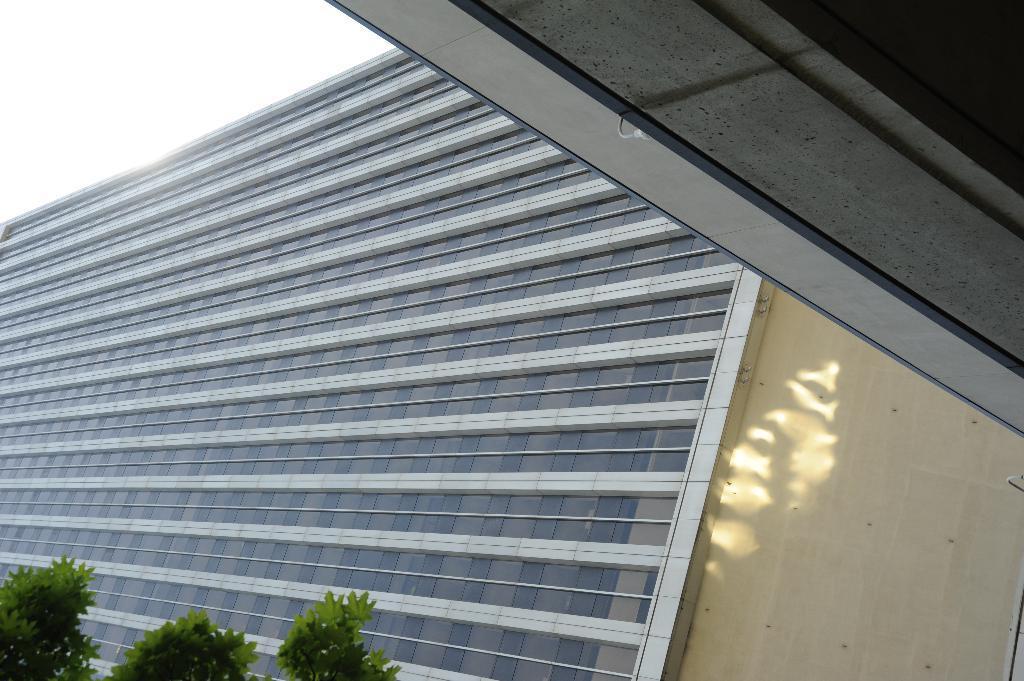Please provide a concise description of this image. At the top right side of the image there is a roof. In the background, we can see the sky, one building, wall, glass and branches with leaves. 